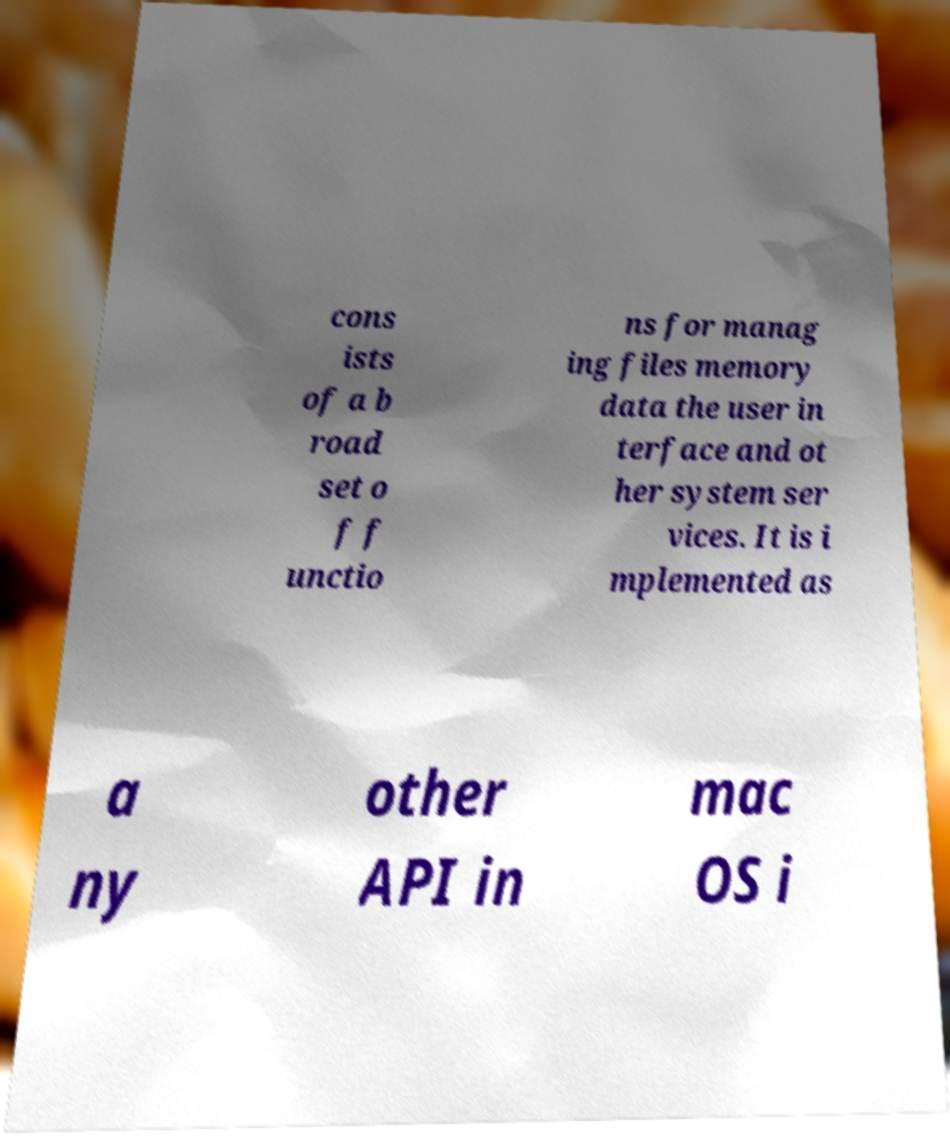Please read and relay the text visible in this image. What does it say? cons ists of a b road set o f f unctio ns for manag ing files memory data the user in terface and ot her system ser vices. It is i mplemented as a ny other API in mac OS i 